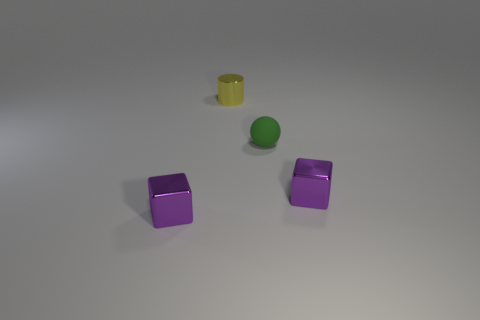Is there any other thing that is the same material as the green object?
Keep it short and to the point. No. Are the purple thing that is to the left of the ball and the small green object that is in front of the cylinder made of the same material?
Your answer should be compact. No. There is a tiny purple metallic object that is left of the small metallic cylinder; what shape is it?
Your answer should be very brief. Cube. How many other things are the same shape as the small green rubber thing?
Ensure brevity in your answer.  0. Does the tiny cube right of the yellow metallic object have the same material as the yellow cylinder?
Provide a succinct answer. Yes. Are there an equal number of metallic cylinders left of the tiny yellow metallic cylinder and things that are on the right side of the tiny rubber thing?
Offer a very short reply. No. Is there a small cube made of the same material as the small yellow object?
Offer a very short reply. Yes. Do the shiny thing that is right of the tiny yellow cylinder and the shiny cylinder have the same color?
Provide a succinct answer. No. Are there the same number of objects that are left of the yellow shiny thing and small green objects?
Your answer should be very brief. Yes. Are there any small matte cubes of the same color as the tiny cylinder?
Keep it short and to the point. No. 